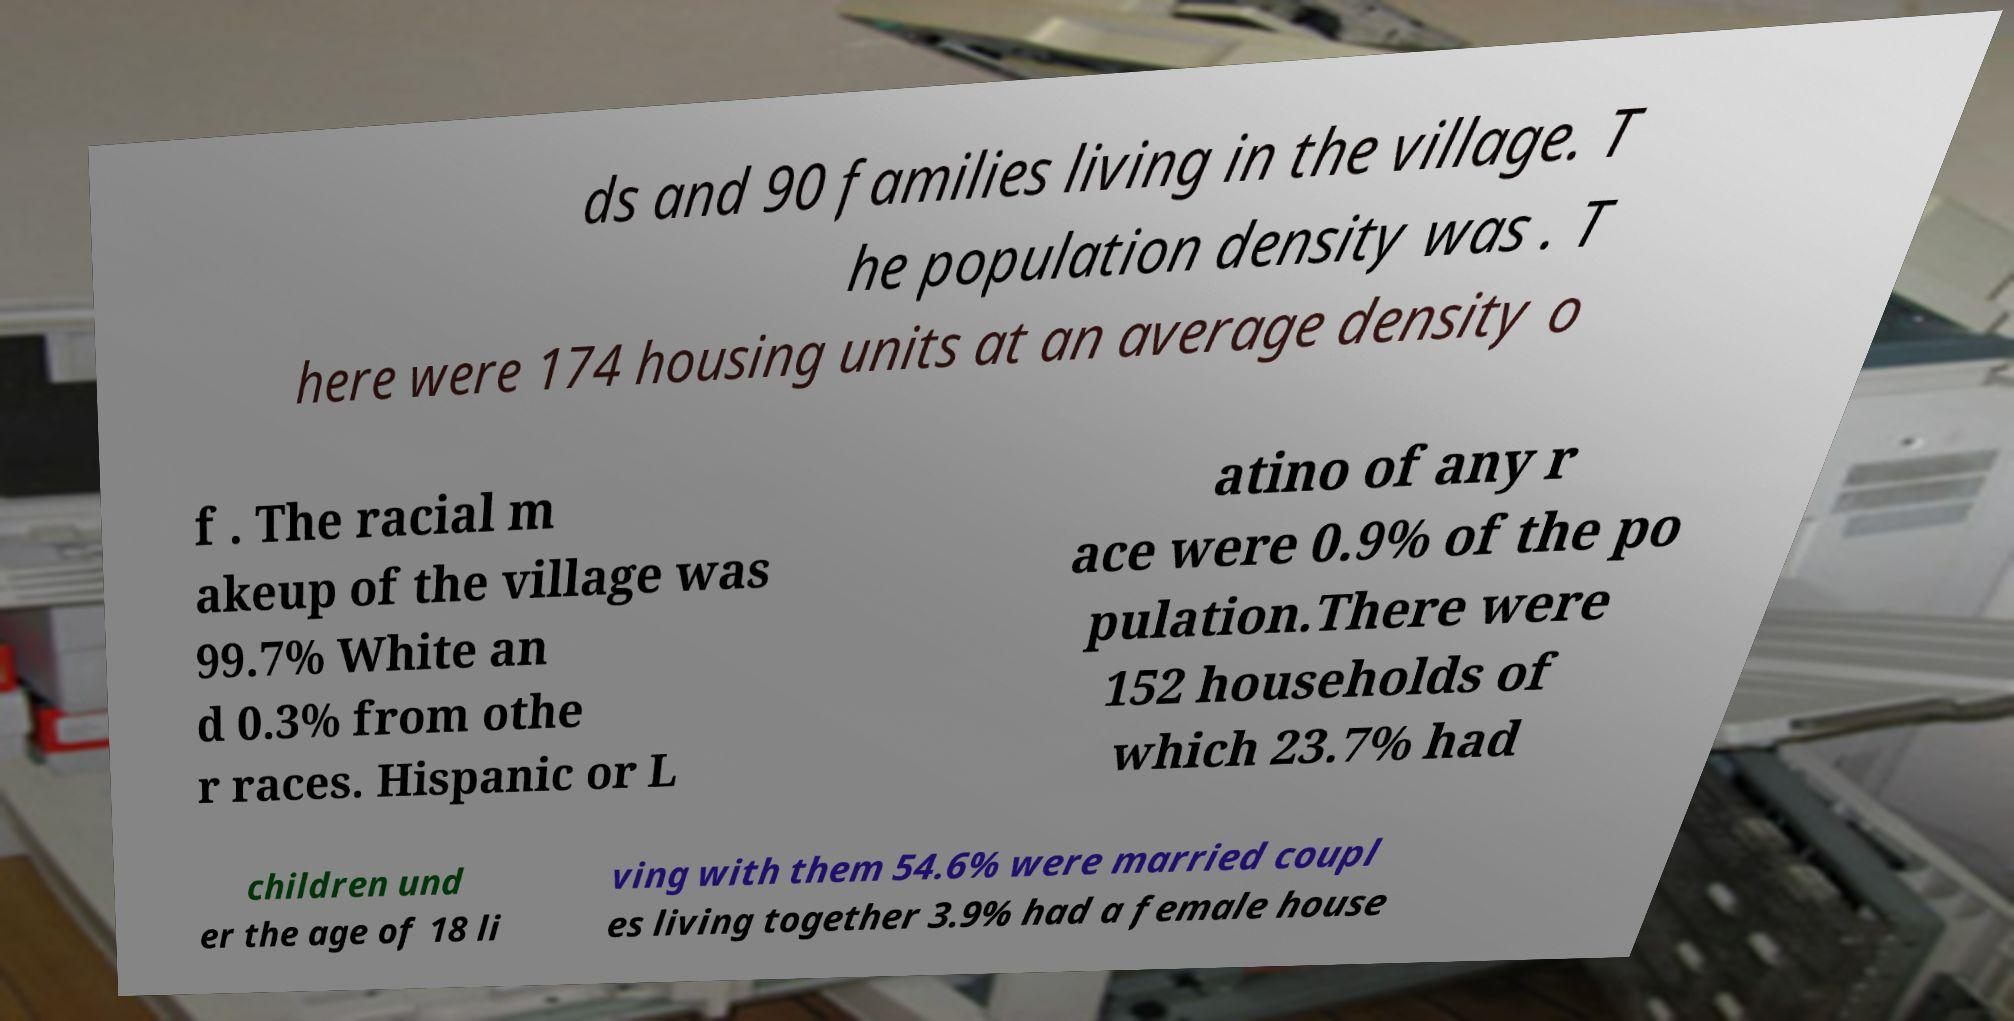There's text embedded in this image that I need extracted. Can you transcribe it verbatim? ds and 90 families living in the village. T he population density was . T here were 174 housing units at an average density o f . The racial m akeup of the village was 99.7% White an d 0.3% from othe r races. Hispanic or L atino of any r ace were 0.9% of the po pulation.There were 152 households of which 23.7% had children und er the age of 18 li ving with them 54.6% were married coupl es living together 3.9% had a female house 